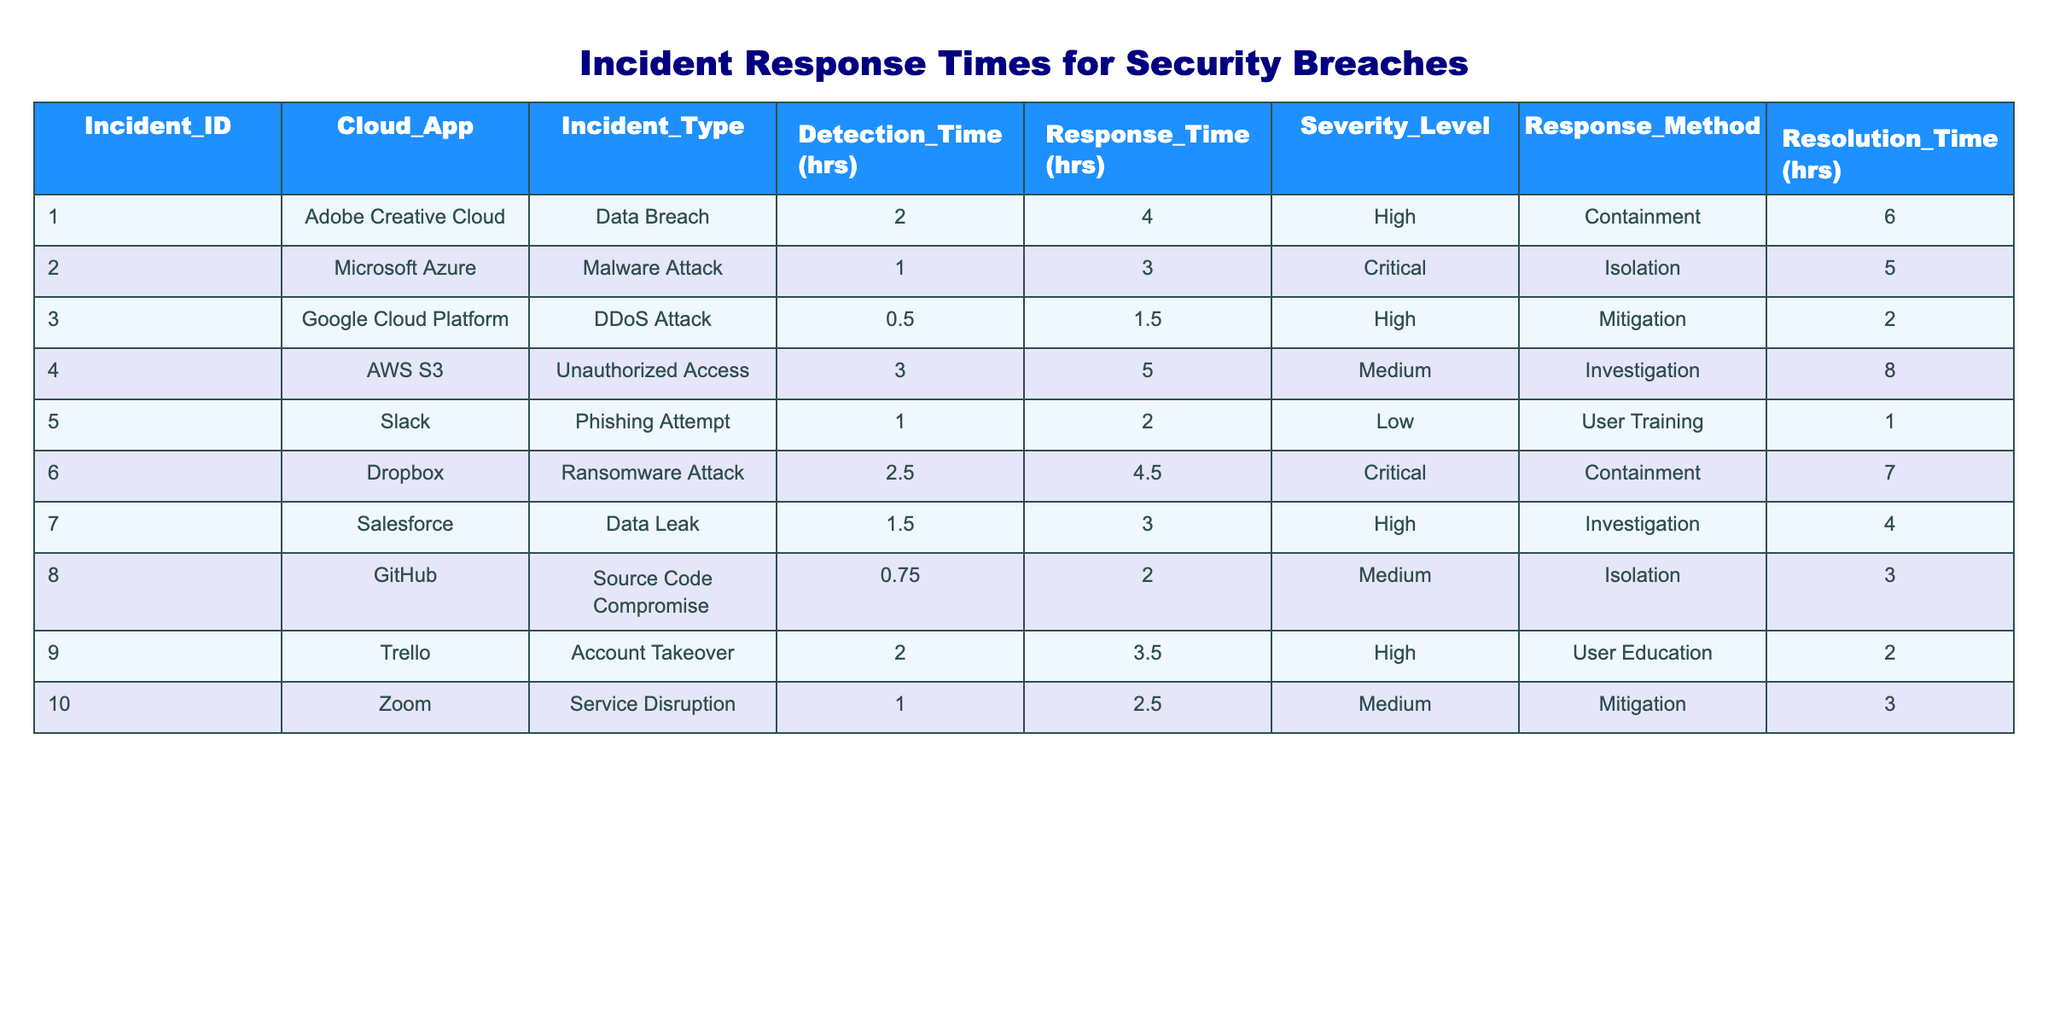What is the detection time for the DDoS attack on Google Cloud Platform? Looking at the row for Google Cloud Platform, the detection time for the DDoS attack is listed in the "Detection_Time (hrs)" column. It clearly states 0.5 hours.
Answer: 0.5 hours Which incident had the longest resolution time? To determine the incident with the longest resolution time, we compare the values in the "Resolution_Time (hrs)" column. The maximum value is 8 hours from the AWS S3 incident involving Unauthorized Access.
Answer: 8 hours What is the average response time for critical incidents? First, we identify the incidents marked as Critical from the "Severity_Level" column, which are incidents 2 and 6. Their response times are 3 hours and 4.5 hours, respectively. By adding these values (3 + 4.5 = 7.5) and dividing by the number of critical incidents (2), we get an average response time of 3.75 hours.
Answer: 3.75 hours Is there a security breach incident with a response time greater than 5 hours? By looking through the "Response_Time (hrs)" column, we see that there are incidents with response times above 5 hours, specifically incidents 4 and 6. Therefore, the answer is yes.
Answer: Yes What incident had the highest severity level and what was its response time? The highest severity level in the table is Critical, which relates to incidents 2 (Malware Attack) and 6 (Ransomware Attack). Their response times are 3 hours and 4.5 hours, respectively. The highest response time for a critical incident is 4.5 hours for the Ransomware Attack.
Answer: 4.5 hours How many incidents involved unauthorized access or data breaches? We can identify incidents with 'Unauthorized Access' (Incident 4) and 'Data Breach' (Incident 1 and Incident 7). Thus, we have 3 incidents in total involving these categories: 1 (Data Breach), 4 (Unauthorized Access), and 7 (Data Leak).
Answer: 3 incidents What percentage of incidents had response times shorter than 3 hours? In the table, we look for incidents with response times shorter than 3 hours. Only incident 3 meets this criterion with a response time of 1.5 hours. With 10 total incidents, the percentage is (1/10) * 100 = 10%.
Answer: 10% Which response method was used the most in the incidents listed? By analyzing the "Response_Method" column, we count the occurrences of each method. We find that 'Containment' appears twice (Incidents 1 and 6) while all others appear less frequently. Thus, Containment is the most commonly used response method.
Answer: Containment 